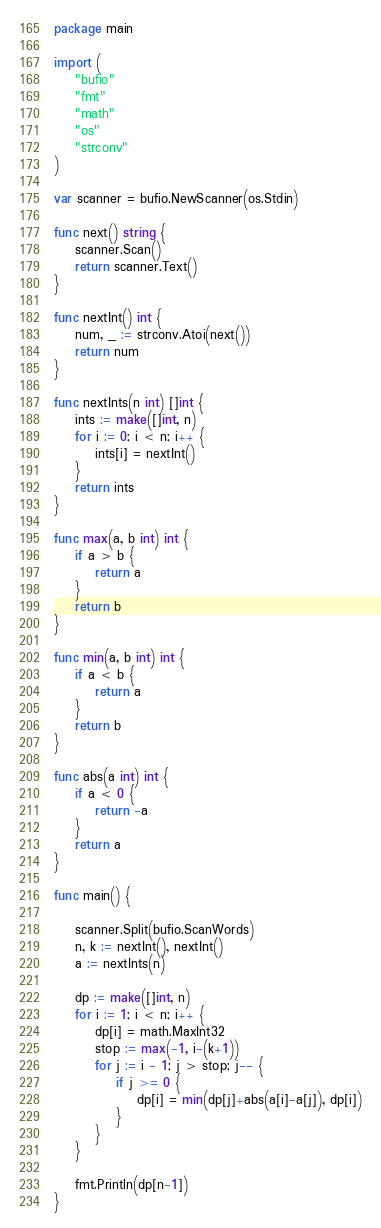Convert code to text. <code><loc_0><loc_0><loc_500><loc_500><_Go_>package main

import (
	"bufio"
	"fmt"
	"math"
	"os"
	"strconv"
)

var scanner = bufio.NewScanner(os.Stdin)

func next() string {
	scanner.Scan()
	return scanner.Text()
}

func nextInt() int {
	num, _ := strconv.Atoi(next())
	return num
}

func nextInts(n int) []int {
	ints := make([]int, n)
	for i := 0; i < n; i++ {
		ints[i] = nextInt()
	}
	return ints
}

func max(a, b int) int {
	if a > b {
		return a
	}
	return b
}

func min(a, b int) int {
	if a < b {
		return a
	}
	return b
}

func abs(a int) int {
	if a < 0 {
		return -a
	}
	return a
}

func main() {

	scanner.Split(bufio.ScanWords)
	n, k := nextInt(), nextInt()
	a := nextInts(n)

	dp := make([]int, n)
	for i := 1; i < n; i++ {
		dp[i] = math.MaxInt32
		stop := max(-1, i-(k+1))
		for j := i - 1; j > stop; j-- {
			if j >= 0 {
				dp[i] = min(dp[j]+abs(a[i]-a[j]), dp[i])
			}
		}
	}

	fmt.Println(dp[n-1])
}
</code> 